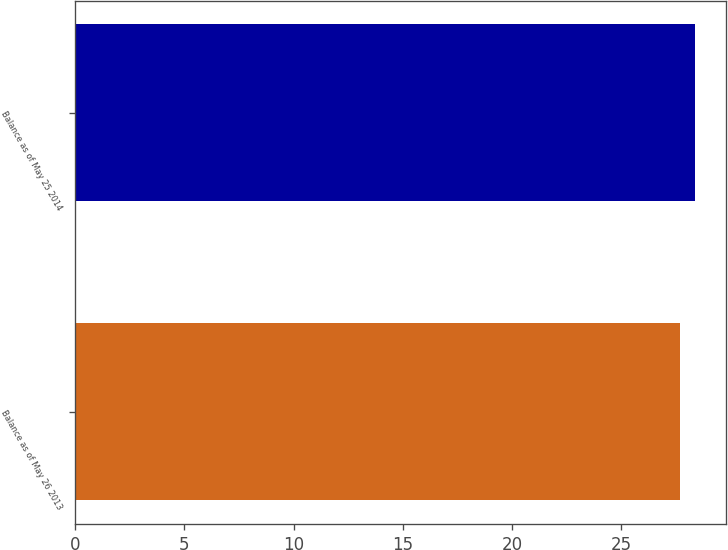<chart> <loc_0><loc_0><loc_500><loc_500><bar_chart><fcel>Balance as of May 26 2013<fcel>Balance as of May 25 2014<nl><fcel>27.69<fcel>28.37<nl></chart> 